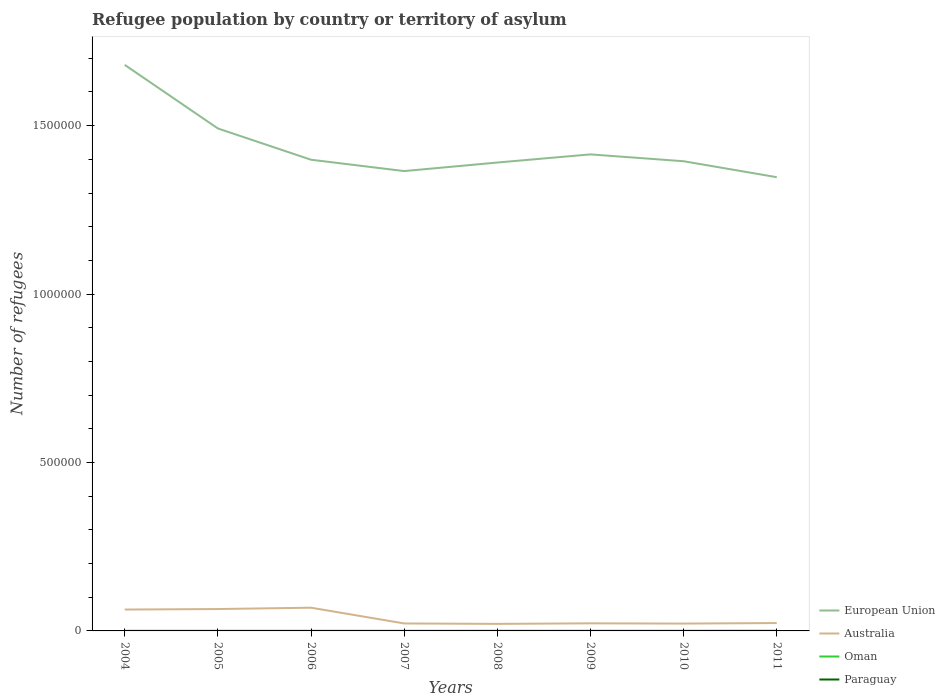How many different coloured lines are there?
Your answer should be very brief. 4. Does the line corresponding to Australia intersect with the line corresponding to Oman?
Provide a succinct answer. No. Is the number of lines equal to the number of legend labels?
Keep it short and to the point. Yes. In which year was the number of refugees in Paraguay maximum?
Provide a succinct answer. 2004. What is the total number of refugees in Australia in the graph?
Provide a succinct answer. -1629. What is the difference between the highest and the second highest number of refugees in Oman?
Offer a very short reply. 76. Is the number of refugees in Paraguay strictly greater than the number of refugees in Australia over the years?
Give a very brief answer. Yes. How many lines are there?
Your answer should be compact. 4. Are the values on the major ticks of Y-axis written in scientific E-notation?
Offer a terse response. No. Does the graph contain grids?
Provide a short and direct response. No. How many legend labels are there?
Provide a short and direct response. 4. What is the title of the graph?
Your response must be concise. Refugee population by country or territory of asylum. Does "Kiribati" appear as one of the legend labels in the graph?
Your answer should be compact. No. What is the label or title of the Y-axis?
Give a very brief answer. Number of refugees. What is the Number of refugees of European Union in 2004?
Provide a succinct answer. 1.68e+06. What is the Number of refugees in Australia in 2004?
Give a very brief answer. 6.35e+04. What is the Number of refugees in European Union in 2005?
Provide a short and direct response. 1.49e+06. What is the Number of refugees of Australia in 2005?
Your response must be concise. 6.50e+04. What is the Number of refugees in European Union in 2006?
Make the answer very short. 1.40e+06. What is the Number of refugees in Australia in 2006?
Make the answer very short. 6.89e+04. What is the Number of refugees in European Union in 2007?
Your answer should be compact. 1.37e+06. What is the Number of refugees of Australia in 2007?
Ensure brevity in your answer.  2.22e+04. What is the Number of refugees of European Union in 2008?
Offer a terse response. 1.39e+06. What is the Number of refugees of Australia in 2008?
Give a very brief answer. 2.09e+04. What is the Number of refugees in Oman in 2008?
Offer a terse response. 7. What is the Number of refugees of Paraguay in 2008?
Give a very brief answer. 75. What is the Number of refugees in European Union in 2009?
Offer a very short reply. 1.41e+06. What is the Number of refugees of Australia in 2009?
Your response must be concise. 2.25e+04. What is the Number of refugees of Paraguay in 2009?
Your response must be concise. 89. What is the Number of refugees in European Union in 2010?
Provide a succinct answer. 1.39e+06. What is the Number of refugees in Australia in 2010?
Keep it short and to the point. 2.18e+04. What is the Number of refugees in Oman in 2010?
Your answer should be very brief. 78. What is the Number of refugees of Paraguay in 2010?
Provide a succinct answer. 107. What is the Number of refugees in European Union in 2011?
Your answer should be very brief. 1.35e+06. What is the Number of refugees in Australia in 2011?
Make the answer very short. 2.34e+04. What is the Number of refugees of Oman in 2011?
Ensure brevity in your answer.  83. What is the Number of refugees in Paraguay in 2011?
Keep it short and to the point. 124. Across all years, what is the maximum Number of refugees in European Union?
Keep it short and to the point. 1.68e+06. Across all years, what is the maximum Number of refugees in Australia?
Offer a very short reply. 6.89e+04. Across all years, what is the maximum Number of refugees in Paraguay?
Ensure brevity in your answer.  124. Across all years, what is the minimum Number of refugees in European Union?
Your answer should be compact. 1.35e+06. Across all years, what is the minimum Number of refugees of Australia?
Keep it short and to the point. 2.09e+04. What is the total Number of refugees in European Union in the graph?
Offer a terse response. 1.15e+07. What is the total Number of refugees in Australia in the graph?
Give a very brief answer. 3.08e+05. What is the total Number of refugees of Oman in the graph?
Ensure brevity in your answer.  222. What is the total Number of refugees in Paraguay in the graph?
Provide a succinct answer. 607. What is the difference between the Number of refugees of European Union in 2004 and that in 2005?
Offer a terse response. 1.89e+05. What is the difference between the Number of refugees in Australia in 2004 and that in 2005?
Your answer should be compact. -1488. What is the difference between the Number of refugees in Oman in 2004 and that in 2005?
Provide a short and direct response. 0. What is the difference between the Number of refugees in European Union in 2004 and that in 2006?
Offer a very short reply. 2.82e+05. What is the difference between the Number of refugees in Australia in 2004 and that in 2006?
Your answer should be compact. -5472. What is the difference between the Number of refugees in Paraguay in 2004 and that in 2006?
Your answer should be very brief. -18. What is the difference between the Number of refugees in European Union in 2004 and that in 2007?
Give a very brief answer. 3.15e+05. What is the difference between the Number of refugees in Australia in 2004 and that in 2007?
Your response must be concise. 4.13e+04. What is the difference between the Number of refugees of Oman in 2004 and that in 2007?
Provide a succinct answer. 0. What is the difference between the Number of refugees of European Union in 2004 and that in 2008?
Your response must be concise. 2.90e+05. What is the difference between the Number of refugees in Australia in 2004 and that in 2008?
Make the answer very short. 4.26e+04. What is the difference between the Number of refugees in Oman in 2004 and that in 2008?
Your response must be concise. 0. What is the difference between the Number of refugees of Paraguay in 2004 and that in 2008?
Your answer should be compact. -34. What is the difference between the Number of refugees of European Union in 2004 and that in 2009?
Provide a short and direct response. 2.66e+05. What is the difference between the Number of refugees of Australia in 2004 and that in 2009?
Your answer should be very brief. 4.09e+04. What is the difference between the Number of refugees in Oman in 2004 and that in 2009?
Provide a succinct answer. -19. What is the difference between the Number of refugees in Paraguay in 2004 and that in 2009?
Your response must be concise. -48. What is the difference between the Number of refugees in European Union in 2004 and that in 2010?
Offer a very short reply. 2.86e+05. What is the difference between the Number of refugees in Australia in 2004 and that in 2010?
Offer a very short reply. 4.17e+04. What is the difference between the Number of refugees of Oman in 2004 and that in 2010?
Provide a succinct answer. -71. What is the difference between the Number of refugees of Paraguay in 2004 and that in 2010?
Give a very brief answer. -66. What is the difference between the Number of refugees in European Union in 2004 and that in 2011?
Provide a short and direct response. 3.33e+05. What is the difference between the Number of refugees in Australia in 2004 and that in 2011?
Offer a terse response. 4.00e+04. What is the difference between the Number of refugees of Oman in 2004 and that in 2011?
Offer a terse response. -76. What is the difference between the Number of refugees in Paraguay in 2004 and that in 2011?
Your answer should be compact. -83. What is the difference between the Number of refugees in European Union in 2005 and that in 2006?
Offer a terse response. 9.28e+04. What is the difference between the Number of refugees of Australia in 2005 and that in 2006?
Your response must be concise. -3984. What is the difference between the Number of refugees in European Union in 2005 and that in 2007?
Your answer should be very brief. 1.27e+05. What is the difference between the Number of refugees of Australia in 2005 and that in 2007?
Ensure brevity in your answer.  4.28e+04. What is the difference between the Number of refugees in Oman in 2005 and that in 2007?
Ensure brevity in your answer.  0. What is the difference between the Number of refugees of European Union in 2005 and that in 2008?
Offer a very short reply. 1.01e+05. What is the difference between the Number of refugees of Australia in 2005 and that in 2008?
Ensure brevity in your answer.  4.40e+04. What is the difference between the Number of refugees in Oman in 2005 and that in 2008?
Keep it short and to the point. 0. What is the difference between the Number of refugees of Paraguay in 2005 and that in 2008?
Your answer should be compact. -25. What is the difference between the Number of refugees in European Union in 2005 and that in 2009?
Offer a terse response. 7.70e+04. What is the difference between the Number of refugees of Australia in 2005 and that in 2009?
Offer a very short reply. 4.24e+04. What is the difference between the Number of refugees of Oman in 2005 and that in 2009?
Your answer should be compact. -19. What is the difference between the Number of refugees of Paraguay in 2005 and that in 2009?
Offer a very short reply. -39. What is the difference between the Number of refugees in European Union in 2005 and that in 2010?
Your answer should be compact. 9.73e+04. What is the difference between the Number of refugees in Australia in 2005 and that in 2010?
Your answer should be compact. 4.32e+04. What is the difference between the Number of refugees in Oman in 2005 and that in 2010?
Your response must be concise. -71. What is the difference between the Number of refugees in Paraguay in 2005 and that in 2010?
Give a very brief answer. -57. What is the difference between the Number of refugees in European Union in 2005 and that in 2011?
Your response must be concise. 1.45e+05. What is the difference between the Number of refugees in Australia in 2005 and that in 2011?
Give a very brief answer. 4.15e+04. What is the difference between the Number of refugees in Oman in 2005 and that in 2011?
Keep it short and to the point. -76. What is the difference between the Number of refugees of Paraguay in 2005 and that in 2011?
Your answer should be very brief. -74. What is the difference between the Number of refugees of European Union in 2006 and that in 2007?
Give a very brief answer. 3.37e+04. What is the difference between the Number of refugees of Australia in 2006 and that in 2007?
Give a very brief answer. 4.68e+04. What is the difference between the Number of refugees of Paraguay in 2006 and that in 2007?
Ensure brevity in your answer.  -3. What is the difference between the Number of refugees of European Union in 2006 and that in 2008?
Your answer should be very brief. 8328. What is the difference between the Number of refugees in Australia in 2006 and that in 2008?
Ensure brevity in your answer.  4.80e+04. What is the difference between the Number of refugees of Oman in 2006 and that in 2008?
Provide a short and direct response. 0. What is the difference between the Number of refugees of Paraguay in 2006 and that in 2008?
Offer a very short reply. -16. What is the difference between the Number of refugees of European Union in 2006 and that in 2009?
Your answer should be compact. -1.59e+04. What is the difference between the Number of refugees in Australia in 2006 and that in 2009?
Give a very brief answer. 4.64e+04. What is the difference between the Number of refugees in European Union in 2006 and that in 2010?
Ensure brevity in your answer.  4486. What is the difference between the Number of refugees of Australia in 2006 and that in 2010?
Your response must be concise. 4.71e+04. What is the difference between the Number of refugees of Oman in 2006 and that in 2010?
Provide a short and direct response. -71. What is the difference between the Number of refugees in Paraguay in 2006 and that in 2010?
Provide a succinct answer. -48. What is the difference between the Number of refugees of European Union in 2006 and that in 2011?
Provide a succinct answer. 5.18e+04. What is the difference between the Number of refugees of Australia in 2006 and that in 2011?
Offer a terse response. 4.55e+04. What is the difference between the Number of refugees in Oman in 2006 and that in 2011?
Offer a very short reply. -76. What is the difference between the Number of refugees of Paraguay in 2006 and that in 2011?
Offer a very short reply. -65. What is the difference between the Number of refugees of European Union in 2007 and that in 2008?
Ensure brevity in your answer.  -2.54e+04. What is the difference between the Number of refugees of Australia in 2007 and that in 2008?
Provide a succinct answer. 1245. What is the difference between the Number of refugees of European Union in 2007 and that in 2009?
Provide a succinct answer. -4.96e+04. What is the difference between the Number of refugees in Australia in 2007 and that in 2009?
Make the answer very short. -384. What is the difference between the Number of refugees in European Union in 2007 and that in 2010?
Your response must be concise. -2.92e+04. What is the difference between the Number of refugees in Australia in 2007 and that in 2010?
Ensure brevity in your answer.  359. What is the difference between the Number of refugees of Oman in 2007 and that in 2010?
Your answer should be compact. -71. What is the difference between the Number of refugees of Paraguay in 2007 and that in 2010?
Make the answer very short. -45. What is the difference between the Number of refugees in European Union in 2007 and that in 2011?
Give a very brief answer. 1.81e+04. What is the difference between the Number of refugees in Australia in 2007 and that in 2011?
Your answer should be very brief. -1270. What is the difference between the Number of refugees of Oman in 2007 and that in 2011?
Provide a succinct answer. -76. What is the difference between the Number of refugees of Paraguay in 2007 and that in 2011?
Provide a short and direct response. -62. What is the difference between the Number of refugees of European Union in 2008 and that in 2009?
Offer a terse response. -2.42e+04. What is the difference between the Number of refugees in Australia in 2008 and that in 2009?
Ensure brevity in your answer.  -1629. What is the difference between the Number of refugees in Paraguay in 2008 and that in 2009?
Ensure brevity in your answer.  -14. What is the difference between the Number of refugees of European Union in 2008 and that in 2010?
Give a very brief answer. -3842. What is the difference between the Number of refugees in Australia in 2008 and that in 2010?
Your answer should be compact. -886. What is the difference between the Number of refugees of Oman in 2008 and that in 2010?
Provide a short and direct response. -71. What is the difference between the Number of refugees in Paraguay in 2008 and that in 2010?
Offer a terse response. -32. What is the difference between the Number of refugees in European Union in 2008 and that in 2011?
Provide a succinct answer. 4.35e+04. What is the difference between the Number of refugees of Australia in 2008 and that in 2011?
Make the answer very short. -2515. What is the difference between the Number of refugees in Oman in 2008 and that in 2011?
Provide a short and direct response. -76. What is the difference between the Number of refugees in Paraguay in 2008 and that in 2011?
Offer a terse response. -49. What is the difference between the Number of refugees of European Union in 2009 and that in 2010?
Your answer should be very brief. 2.04e+04. What is the difference between the Number of refugees in Australia in 2009 and that in 2010?
Ensure brevity in your answer.  743. What is the difference between the Number of refugees of Oman in 2009 and that in 2010?
Offer a very short reply. -52. What is the difference between the Number of refugees in Paraguay in 2009 and that in 2010?
Keep it short and to the point. -18. What is the difference between the Number of refugees of European Union in 2009 and that in 2011?
Offer a terse response. 6.77e+04. What is the difference between the Number of refugees in Australia in 2009 and that in 2011?
Ensure brevity in your answer.  -886. What is the difference between the Number of refugees of Oman in 2009 and that in 2011?
Keep it short and to the point. -57. What is the difference between the Number of refugees in Paraguay in 2009 and that in 2011?
Your answer should be very brief. -35. What is the difference between the Number of refugees in European Union in 2010 and that in 2011?
Your answer should be very brief. 4.73e+04. What is the difference between the Number of refugees of Australia in 2010 and that in 2011?
Make the answer very short. -1629. What is the difference between the Number of refugees of Oman in 2010 and that in 2011?
Provide a succinct answer. -5. What is the difference between the Number of refugees of European Union in 2004 and the Number of refugees of Australia in 2005?
Keep it short and to the point. 1.62e+06. What is the difference between the Number of refugees in European Union in 2004 and the Number of refugees in Oman in 2005?
Offer a very short reply. 1.68e+06. What is the difference between the Number of refugees of European Union in 2004 and the Number of refugees of Paraguay in 2005?
Ensure brevity in your answer.  1.68e+06. What is the difference between the Number of refugees of Australia in 2004 and the Number of refugees of Oman in 2005?
Provide a succinct answer. 6.35e+04. What is the difference between the Number of refugees of Australia in 2004 and the Number of refugees of Paraguay in 2005?
Your answer should be very brief. 6.34e+04. What is the difference between the Number of refugees of Oman in 2004 and the Number of refugees of Paraguay in 2005?
Ensure brevity in your answer.  -43. What is the difference between the Number of refugees in European Union in 2004 and the Number of refugees in Australia in 2006?
Keep it short and to the point. 1.61e+06. What is the difference between the Number of refugees in European Union in 2004 and the Number of refugees in Oman in 2006?
Make the answer very short. 1.68e+06. What is the difference between the Number of refugees of European Union in 2004 and the Number of refugees of Paraguay in 2006?
Make the answer very short. 1.68e+06. What is the difference between the Number of refugees in Australia in 2004 and the Number of refugees in Oman in 2006?
Provide a succinct answer. 6.35e+04. What is the difference between the Number of refugees of Australia in 2004 and the Number of refugees of Paraguay in 2006?
Provide a succinct answer. 6.34e+04. What is the difference between the Number of refugees in Oman in 2004 and the Number of refugees in Paraguay in 2006?
Offer a very short reply. -52. What is the difference between the Number of refugees of European Union in 2004 and the Number of refugees of Australia in 2007?
Your answer should be very brief. 1.66e+06. What is the difference between the Number of refugees in European Union in 2004 and the Number of refugees in Oman in 2007?
Your response must be concise. 1.68e+06. What is the difference between the Number of refugees of European Union in 2004 and the Number of refugees of Paraguay in 2007?
Offer a very short reply. 1.68e+06. What is the difference between the Number of refugees in Australia in 2004 and the Number of refugees in Oman in 2007?
Give a very brief answer. 6.35e+04. What is the difference between the Number of refugees in Australia in 2004 and the Number of refugees in Paraguay in 2007?
Provide a short and direct response. 6.34e+04. What is the difference between the Number of refugees of Oman in 2004 and the Number of refugees of Paraguay in 2007?
Offer a terse response. -55. What is the difference between the Number of refugees of European Union in 2004 and the Number of refugees of Australia in 2008?
Ensure brevity in your answer.  1.66e+06. What is the difference between the Number of refugees in European Union in 2004 and the Number of refugees in Oman in 2008?
Provide a succinct answer. 1.68e+06. What is the difference between the Number of refugees in European Union in 2004 and the Number of refugees in Paraguay in 2008?
Offer a very short reply. 1.68e+06. What is the difference between the Number of refugees of Australia in 2004 and the Number of refugees of Oman in 2008?
Make the answer very short. 6.35e+04. What is the difference between the Number of refugees of Australia in 2004 and the Number of refugees of Paraguay in 2008?
Your answer should be very brief. 6.34e+04. What is the difference between the Number of refugees in Oman in 2004 and the Number of refugees in Paraguay in 2008?
Offer a terse response. -68. What is the difference between the Number of refugees of European Union in 2004 and the Number of refugees of Australia in 2009?
Your answer should be very brief. 1.66e+06. What is the difference between the Number of refugees of European Union in 2004 and the Number of refugees of Oman in 2009?
Give a very brief answer. 1.68e+06. What is the difference between the Number of refugees in European Union in 2004 and the Number of refugees in Paraguay in 2009?
Offer a terse response. 1.68e+06. What is the difference between the Number of refugees of Australia in 2004 and the Number of refugees of Oman in 2009?
Make the answer very short. 6.34e+04. What is the difference between the Number of refugees of Australia in 2004 and the Number of refugees of Paraguay in 2009?
Your answer should be compact. 6.34e+04. What is the difference between the Number of refugees in Oman in 2004 and the Number of refugees in Paraguay in 2009?
Ensure brevity in your answer.  -82. What is the difference between the Number of refugees of European Union in 2004 and the Number of refugees of Australia in 2010?
Your answer should be very brief. 1.66e+06. What is the difference between the Number of refugees in European Union in 2004 and the Number of refugees in Oman in 2010?
Your response must be concise. 1.68e+06. What is the difference between the Number of refugees in European Union in 2004 and the Number of refugees in Paraguay in 2010?
Offer a terse response. 1.68e+06. What is the difference between the Number of refugees in Australia in 2004 and the Number of refugees in Oman in 2010?
Your answer should be compact. 6.34e+04. What is the difference between the Number of refugees in Australia in 2004 and the Number of refugees in Paraguay in 2010?
Give a very brief answer. 6.34e+04. What is the difference between the Number of refugees in Oman in 2004 and the Number of refugees in Paraguay in 2010?
Make the answer very short. -100. What is the difference between the Number of refugees of European Union in 2004 and the Number of refugees of Australia in 2011?
Ensure brevity in your answer.  1.66e+06. What is the difference between the Number of refugees of European Union in 2004 and the Number of refugees of Oman in 2011?
Your answer should be very brief. 1.68e+06. What is the difference between the Number of refugees in European Union in 2004 and the Number of refugees in Paraguay in 2011?
Provide a succinct answer. 1.68e+06. What is the difference between the Number of refugees in Australia in 2004 and the Number of refugees in Oman in 2011?
Provide a short and direct response. 6.34e+04. What is the difference between the Number of refugees of Australia in 2004 and the Number of refugees of Paraguay in 2011?
Keep it short and to the point. 6.34e+04. What is the difference between the Number of refugees in Oman in 2004 and the Number of refugees in Paraguay in 2011?
Ensure brevity in your answer.  -117. What is the difference between the Number of refugees in European Union in 2005 and the Number of refugees in Australia in 2006?
Give a very brief answer. 1.42e+06. What is the difference between the Number of refugees of European Union in 2005 and the Number of refugees of Oman in 2006?
Provide a succinct answer. 1.49e+06. What is the difference between the Number of refugees of European Union in 2005 and the Number of refugees of Paraguay in 2006?
Keep it short and to the point. 1.49e+06. What is the difference between the Number of refugees of Australia in 2005 and the Number of refugees of Oman in 2006?
Offer a very short reply. 6.50e+04. What is the difference between the Number of refugees in Australia in 2005 and the Number of refugees in Paraguay in 2006?
Your response must be concise. 6.49e+04. What is the difference between the Number of refugees in Oman in 2005 and the Number of refugees in Paraguay in 2006?
Your answer should be very brief. -52. What is the difference between the Number of refugees of European Union in 2005 and the Number of refugees of Australia in 2007?
Offer a very short reply. 1.47e+06. What is the difference between the Number of refugees in European Union in 2005 and the Number of refugees in Oman in 2007?
Offer a very short reply. 1.49e+06. What is the difference between the Number of refugees of European Union in 2005 and the Number of refugees of Paraguay in 2007?
Provide a succinct answer. 1.49e+06. What is the difference between the Number of refugees of Australia in 2005 and the Number of refugees of Oman in 2007?
Give a very brief answer. 6.50e+04. What is the difference between the Number of refugees of Australia in 2005 and the Number of refugees of Paraguay in 2007?
Ensure brevity in your answer.  6.49e+04. What is the difference between the Number of refugees of Oman in 2005 and the Number of refugees of Paraguay in 2007?
Offer a terse response. -55. What is the difference between the Number of refugees in European Union in 2005 and the Number of refugees in Australia in 2008?
Your response must be concise. 1.47e+06. What is the difference between the Number of refugees of European Union in 2005 and the Number of refugees of Oman in 2008?
Your answer should be compact. 1.49e+06. What is the difference between the Number of refugees in European Union in 2005 and the Number of refugees in Paraguay in 2008?
Your answer should be very brief. 1.49e+06. What is the difference between the Number of refugees of Australia in 2005 and the Number of refugees of Oman in 2008?
Keep it short and to the point. 6.50e+04. What is the difference between the Number of refugees of Australia in 2005 and the Number of refugees of Paraguay in 2008?
Ensure brevity in your answer.  6.49e+04. What is the difference between the Number of refugees in Oman in 2005 and the Number of refugees in Paraguay in 2008?
Make the answer very short. -68. What is the difference between the Number of refugees in European Union in 2005 and the Number of refugees in Australia in 2009?
Your answer should be very brief. 1.47e+06. What is the difference between the Number of refugees in European Union in 2005 and the Number of refugees in Oman in 2009?
Make the answer very short. 1.49e+06. What is the difference between the Number of refugees of European Union in 2005 and the Number of refugees of Paraguay in 2009?
Offer a terse response. 1.49e+06. What is the difference between the Number of refugees of Australia in 2005 and the Number of refugees of Oman in 2009?
Provide a short and direct response. 6.49e+04. What is the difference between the Number of refugees of Australia in 2005 and the Number of refugees of Paraguay in 2009?
Ensure brevity in your answer.  6.49e+04. What is the difference between the Number of refugees of Oman in 2005 and the Number of refugees of Paraguay in 2009?
Your answer should be compact. -82. What is the difference between the Number of refugees of European Union in 2005 and the Number of refugees of Australia in 2010?
Keep it short and to the point. 1.47e+06. What is the difference between the Number of refugees in European Union in 2005 and the Number of refugees in Oman in 2010?
Offer a terse response. 1.49e+06. What is the difference between the Number of refugees of European Union in 2005 and the Number of refugees of Paraguay in 2010?
Your answer should be compact. 1.49e+06. What is the difference between the Number of refugees in Australia in 2005 and the Number of refugees in Oman in 2010?
Your answer should be compact. 6.49e+04. What is the difference between the Number of refugees in Australia in 2005 and the Number of refugees in Paraguay in 2010?
Your answer should be very brief. 6.49e+04. What is the difference between the Number of refugees in Oman in 2005 and the Number of refugees in Paraguay in 2010?
Offer a terse response. -100. What is the difference between the Number of refugees in European Union in 2005 and the Number of refugees in Australia in 2011?
Keep it short and to the point. 1.47e+06. What is the difference between the Number of refugees of European Union in 2005 and the Number of refugees of Oman in 2011?
Your answer should be compact. 1.49e+06. What is the difference between the Number of refugees of European Union in 2005 and the Number of refugees of Paraguay in 2011?
Provide a succinct answer. 1.49e+06. What is the difference between the Number of refugees in Australia in 2005 and the Number of refugees in Oman in 2011?
Offer a very short reply. 6.49e+04. What is the difference between the Number of refugees in Australia in 2005 and the Number of refugees in Paraguay in 2011?
Make the answer very short. 6.48e+04. What is the difference between the Number of refugees of Oman in 2005 and the Number of refugees of Paraguay in 2011?
Provide a short and direct response. -117. What is the difference between the Number of refugees of European Union in 2006 and the Number of refugees of Australia in 2007?
Offer a very short reply. 1.38e+06. What is the difference between the Number of refugees in European Union in 2006 and the Number of refugees in Oman in 2007?
Your answer should be compact. 1.40e+06. What is the difference between the Number of refugees in European Union in 2006 and the Number of refugees in Paraguay in 2007?
Your answer should be very brief. 1.40e+06. What is the difference between the Number of refugees in Australia in 2006 and the Number of refugees in Oman in 2007?
Ensure brevity in your answer.  6.89e+04. What is the difference between the Number of refugees in Australia in 2006 and the Number of refugees in Paraguay in 2007?
Offer a very short reply. 6.89e+04. What is the difference between the Number of refugees in Oman in 2006 and the Number of refugees in Paraguay in 2007?
Ensure brevity in your answer.  -55. What is the difference between the Number of refugees of European Union in 2006 and the Number of refugees of Australia in 2008?
Keep it short and to the point. 1.38e+06. What is the difference between the Number of refugees of European Union in 2006 and the Number of refugees of Oman in 2008?
Offer a terse response. 1.40e+06. What is the difference between the Number of refugees of European Union in 2006 and the Number of refugees of Paraguay in 2008?
Provide a short and direct response. 1.40e+06. What is the difference between the Number of refugees of Australia in 2006 and the Number of refugees of Oman in 2008?
Offer a terse response. 6.89e+04. What is the difference between the Number of refugees in Australia in 2006 and the Number of refugees in Paraguay in 2008?
Offer a terse response. 6.89e+04. What is the difference between the Number of refugees of Oman in 2006 and the Number of refugees of Paraguay in 2008?
Your answer should be compact. -68. What is the difference between the Number of refugees in European Union in 2006 and the Number of refugees in Australia in 2009?
Your answer should be compact. 1.38e+06. What is the difference between the Number of refugees in European Union in 2006 and the Number of refugees in Oman in 2009?
Make the answer very short. 1.40e+06. What is the difference between the Number of refugees in European Union in 2006 and the Number of refugees in Paraguay in 2009?
Offer a terse response. 1.40e+06. What is the difference between the Number of refugees of Australia in 2006 and the Number of refugees of Oman in 2009?
Provide a short and direct response. 6.89e+04. What is the difference between the Number of refugees of Australia in 2006 and the Number of refugees of Paraguay in 2009?
Your response must be concise. 6.89e+04. What is the difference between the Number of refugees of Oman in 2006 and the Number of refugees of Paraguay in 2009?
Give a very brief answer. -82. What is the difference between the Number of refugees in European Union in 2006 and the Number of refugees in Australia in 2010?
Your response must be concise. 1.38e+06. What is the difference between the Number of refugees in European Union in 2006 and the Number of refugees in Oman in 2010?
Your response must be concise. 1.40e+06. What is the difference between the Number of refugees in European Union in 2006 and the Number of refugees in Paraguay in 2010?
Your answer should be very brief. 1.40e+06. What is the difference between the Number of refugees of Australia in 2006 and the Number of refugees of Oman in 2010?
Give a very brief answer. 6.89e+04. What is the difference between the Number of refugees in Australia in 2006 and the Number of refugees in Paraguay in 2010?
Ensure brevity in your answer.  6.88e+04. What is the difference between the Number of refugees in Oman in 2006 and the Number of refugees in Paraguay in 2010?
Your response must be concise. -100. What is the difference between the Number of refugees in European Union in 2006 and the Number of refugees in Australia in 2011?
Offer a terse response. 1.38e+06. What is the difference between the Number of refugees of European Union in 2006 and the Number of refugees of Oman in 2011?
Provide a short and direct response. 1.40e+06. What is the difference between the Number of refugees of European Union in 2006 and the Number of refugees of Paraguay in 2011?
Offer a very short reply. 1.40e+06. What is the difference between the Number of refugees in Australia in 2006 and the Number of refugees in Oman in 2011?
Your answer should be very brief. 6.89e+04. What is the difference between the Number of refugees in Australia in 2006 and the Number of refugees in Paraguay in 2011?
Your answer should be very brief. 6.88e+04. What is the difference between the Number of refugees in Oman in 2006 and the Number of refugees in Paraguay in 2011?
Offer a terse response. -117. What is the difference between the Number of refugees of European Union in 2007 and the Number of refugees of Australia in 2008?
Make the answer very short. 1.34e+06. What is the difference between the Number of refugees of European Union in 2007 and the Number of refugees of Oman in 2008?
Keep it short and to the point. 1.37e+06. What is the difference between the Number of refugees in European Union in 2007 and the Number of refugees in Paraguay in 2008?
Keep it short and to the point. 1.37e+06. What is the difference between the Number of refugees of Australia in 2007 and the Number of refugees of Oman in 2008?
Your response must be concise. 2.22e+04. What is the difference between the Number of refugees of Australia in 2007 and the Number of refugees of Paraguay in 2008?
Give a very brief answer. 2.21e+04. What is the difference between the Number of refugees in Oman in 2007 and the Number of refugees in Paraguay in 2008?
Your answer should be compact. -68. What is the difference between the Number of refugees in European Union in 2007 and the Number of refugees in Australia in 2009?
Provide a succinct answer. 1.34e+06. What is the difference between the Number of refugees of European Union in 2007 and the Number of refugees of Oman in 2009?
Offer a terse response. 1.37e+06. What is the difference between the Number of refugees in European Union in 2007 and the Number of refugees in Paraguay in 2009?
Make the answer very short. 1.37e+06. What is the difference between the Number of refugees of Australia in 2007 and the Number of refugees of Oman in 2009?
Give a very brief answer. 2.21e+04. What is the difference between the Number of refugees of Australia in 2007 and the Number of refugees of Paraguay in 2009?
Your answer should be very brief. 2.21e+04. What is the difference between the Number of refugees of Oman in 2007 and the Number of refugees of Paraguay in 2009?
Offer a very short reply. -82. What is the difference between the Number of refugees of European Union in 2007 and the Number of refugees of Australia in 2010?
Your answer should be compact. 1.34e+06. What is the difference between the Number of refugees of European Union in 2007 and the Number of refugees of Oman in 2010?
Ensure brevity in your answer.  1.37e+06. What is the difference between the Number of refugees in European Union in 2007 and the Number of refugees in Paraguay in 2010?
Your response must be concise. 1.37e+06. What is the difference between the Number of refugees of Australia in 2007 and the Number of refugees of Oman in 2010?
Offer a terse response. 2.21e+04. What is the difference between the Number of refugees in Australia in 2007 and the Number of refugees in Paraguay in 2010?
Keep it short and to the point. 2.21e+04. What is the difference between the Number of refugees of Oman in 2007 and the Number of refugees of Paraguay in 2010?
Your answer should be compact. -100. What is the difference between the Number of refugees in European Union in 2007 and the Number of refugees in Australia in 2011?
Keep it short and to the point. 1.34e+06. What is the difference between the Number of refugees of European Union in 2007 and the Number of refugees of Oman in 2011?
Ensure brevity in your answer.  1.37e+06. What is the difference between the Number of refugees of European Union in 2007 and the Number of refugees of Paraguay in 2011?
Make the answer very short. 1.37e+06. What is the difference between the Number of refugees of Australia in 2007 and the Number of refugees of Oman in 2011?
Give a very brief answer. 2.21e+04. What is the difference between the Number of refugees in Australia in 2007 and the Number of refugees in Paraguay in 2011?
Offer a very short reply. 2.20e+04. What is the difference between the Number of refugees in Oman in 2007 and the Number of refugees in Paraguay in 2011?
Your response must be concise. -117. What is the difference between the Number of refugees in European Union in 2008 and the Number of refugees in Australia in 2009?
Your answer should be compact. 1.37e+06. What is the difference between the Number of refugees in European Union in 2008 and the Number of refugees in Oman in 2009?
Ensure brevity in your answer.  1.39e+06. What is the difference between the Number of refugees in European Union in 2008 and the Number of refugees in Paraguay in 2009?
Offer a terse response. 1.39e+06. What is the difference between the Number of refugees of Australia in 2008 and the Number of refugees of Oman in 2009?
Make the answer very short. 2.09e+04. What is the difference between the Number of refugees of Australia in 2008 and the Number of refugees of Paraguay in 2009?
Provide a short and direct response. 2.08e+04. What is the difference between the Number of refugees in Oman in 2008 and the Number of refugees in Paraguay in 2009?
Ensure brevity in your answer.  -82. What is the difference between the Number of refugees of European Union in 2008 and the Number of refugees of Australia in 2010?
Give a very brief answer. 1.37e+06. What is the difference between the Number of refugees of European Union in 2008 and the Number of refugees of Oman in 2010?
Your answer should be very brief. 1.39e+06. What is the difference between the Number of refugees of European Union in 2008 and the Number of refugees of Paraguay in 2010?
Offer a terse response. 1.39e+06. What is the difference between the Number of refugees of Australia in 2008 and the Number of refugees of Oman in 2010?
Provide a succinct answer. 2.08e+04. What is the difference between the Number of refugees in Australia in 2008 and the Number of refugees in Paraguay in 2010?
Offer a very short reply. 2.08e+04. What is the difference between the Number of refugees of Oman in 2008 and the Number of refugees of Paraguay in 2010?
Provide a short and direct response. -100. What is the difference between the Number of refugees of European Union in 2008 and the Number of refugees of Australia in 2011?
Offer a very short reply. 1.37e+06. What is the difference between the Number of refugees in European Union in 2008 and the Number of refugees in Oman in 2011?
Give a very brief answer. 1.39e+06. What is the difference between the Number of refugees of European Union in 2008 and the Number of refugees of Paraguay in 2011?
Your response must be concise. 1.39e+06. What is the difference between the Number of refugees in Australia in 2008 and the Number of refugees in Oman in 2011?
Offer a terse response. 2.08e+04. What is the difference between the Number of refugees of Australia in 2008 and the Number of refugees of Paraguay in 2011?
Provide a short and direct response. 2.08e+04. What is the difference between the Number of refugees of Oman in 2008 and the Number of refugees of Paraguay in 2011?
Your answer should be compact. -117. What is the difference between the Number of refugees of European Union in 2009 and the Number of refugees of Australia in 2010?
Provide a short and direct response. 1.39e+06. What is the difference between the Number of refugees of European Union in 2009 and the Number of refugees of Oman in 2010?
Provide a short and direct response. 1.41e+06. What is the difference between the Number of refugees of European Union in 2009 and the Number of refugees of Paraguay in 2010?
Your answer should be compact. 1.41e+06. What is the difference between the Number of refugees in Australia in 2009 and the Number of refugees in Oman in 2010?
Offer a very short reply. 2.25e+04. What is the difference between the Number of refugees of Australia in 2009 and the Number of refugees of Paraguay in 2010?
Keep it short and to the point. 2.24e+04. What is the difference between the Number of refugees in Oman in 2009 and the Number of refugees in Paraguay in 2010?
Ensure brevity in your answer.  -81. What is the difference between the Number of refugees of European Union in 2009 and the Number of refugees of Australia in 2011?
Offer a terse response. 1.39e+06. What is the difference between the Number of refugees of European Union in 2009 and the Number of refugees of Oman in 2011?
Offer a very short reply. 1.41e+06. What is the difference between the Number of refugees in European Union in 2009 and the Number of refugees in Paraguay in 2011?
Your answer should be very brief. 1.41e+06. What is the difference between the Number of refugees of Australia in 2009 and the Number of refugees of Oman in 2011?
Give a very brief answer. 2.25e+04. What is the difference between the Number of refugees in Australia in 2009 and the Number of refugees in Paraguay in 2011?
Offer a very short reply. 2.24e+04. What is the difference between the Number of refugees of Oman in 2009 and the Number of refugees of Paraguay in 2011?
Offer a terse response. -98. What is the difference between the Number of refugees of European Union in 2010 and the Number of refugees of Australia in 2011?
Keep it short and to the point. 1.37e+06. What is the difference between the Number of refugees of European Union in 2010 and the Number of refugees of Oman in 2011?
Keep it short and to the point. 1.39e+06. What is the difference between the Number of refugees of European Union in 2010 and the Number of refugees of Paraguay in 2011?
Make the answer very short. 1.39e+06. What is the difference between the Number of refugees in Australia in 2010 and the Number of refugees in Oman in 2011?
Provide a short and direct response. 2.17e+04. What is the difference between the Number of refugees of Australia in 2010 and the Number of refugees of Paraguay in 2011?
Your response must be concise. 2.17e+04. What is the difference between the Number of refugees of Oman in 2010 and the Number of refugees of Paraguay in 2011?
Keep it short and to the point. -46. What is the average Number of refugees in European Union per year?
Offer a terse response. 1.44e+06. What is the average Number of refugees of Australia per year?
Give a very brief answer. 3.85e+04. What is the average Number of refugees of Oman per year?
Your answer should be very brief. 27.75. What is the average Number of refugees in Paraguay per year?
Offer a very short reply. 75.88. In the year 2004, what is the difference between the Number of refugees of European Union and Number of refugees of Australia?
Provide a short and direct response. 1.62e+06. In the year 2004, what is the difference between the Number of refugees in European Union and Number of refugees in Oman?
Give a very brief answer. 1.68e+06. In the year 2004, what is the difference between the Number of refugees in European Union and Number of refugees in Paraguay?
Give a very brief answer. 1.68e+06. In the year 2004, what is the difference between the Number of refugees in Australia and Number of refugees in Oman?
Keep it short and to the point. 6.35e+04. In the year 2004, what is the difference between the Number of refugees in Australia and Number of refugees in Paraguay?
Ensure brevity in your answer.  6.34e+04. In the year 2004, what is the difference between the Number of refugees in Oman and Number of refugees in Paraguay?
Provide a succinct answer. -34. In the year 2005, what is the difference between the Number of refugees of European Union and Number of refugees of Australia?
Your answer should be compact. 1.43e+06. In the year 2005, what is the difference between the Number of refugees in European Union and Number of refugees in Oman?
Give a very brief answer. 1.49e+06. In the year 2005, what is the difference between the Number of refugees in European Union and Number of refugees in Paraguay?
Make the answer very short. 1.49e+06. In the year 2005, what is the difference between the Number of refugees in Australia and Number of refugees in Oman?
Your answer should be very brief. 6.50e+04. In the year 2005, what is the difference between the Number of refugees of Australia and Number of refugees of Paraguay?
Your response must be concise. 6.49e+04. In the year 2005, what is the difference between the Number of refugees in Oman and Number of refugees in Paraguay?
Your answer should be compact. -43. In the year 2006, what is the difference between the Number of refugees in European Union and Number of refugees in Australia?
Your answer should be very brief. 1.33e+06. In the year 2006, what is the difference between the Number of refugees in European Union and Number of refugees in Oman?
Provide a succinct answer. 1.40e+06. In the year 2006, what is the difference between the Number of refugees in European Union and Number of refugees in Paraguay?
Offer a terse response. 1.40e+06. In the year 2006, what is the difference between the Number of refugees of Australia and Number of refugees of Oman?
Give a very brief answer. 6.89e+04. In the year 2006, what is the difference between the Number of refugees in Australia and Number of refugees in Paraguay?
Keep it short and to the point. 6.89e+04. In the year 2006, what is the difference between the Number of refugees of Oman and Number of refugees of Paraguay?
Provide a short and direct response. -52. In the year 2007, what is the difference between the Number of refugees of European Union and Number of refugees of Australia?
Offer a terse response. 1.34e+06. In the year 2007, what is the difference between the Number of refugees in European Union and Number of refugees in Oman?
Ensure brevity in your answer.  1.37e+06. In the year 2007, what is the difference between the Number of refugees in European Union and Number of refugees in Paraguay?
Ensure brevity in your answer.  1.37e+06. In the year 2007, what is the difference between the Number of refugees in Australia and Number of refugees in Oman?
Offer a very short reply. 2.22e+04. In the year 2007, what is the difference between the Number of refugees in Australia and Number of refugees in Paraguay?
Give a very brief answer. 2.21e+04. In the year 2007, what is the difference between the Number of refugees of Oman and Number of refugees of Paraguay?
Offer a very short reply. -55. In the year 2008, what is the difference between the Number of refugees of European Union and Number of refugees of Australia?
Offer a terse response. 1.37e+06. In the year 2008, what is the difference between the Number of refugees of European Union and Number of refugees of Oman?
Keep it short and to the point. 1.39e+06. In the year 2008, what is the difference between the Number of refugees of European Union and Number of refugees of Paraguay?
Your response must be concise. 1.39e+06. In the year 2008, what is the difference between the Number of refugees in Australia and Number of refugees in Oman?
Provide a succinct answer. 2.09e+04. In the year 2008, what is the difference between the Number of refugees in Australia and Number of refugees in Paraguay?
Give a very brief answer. 2.08e+04. In the year 2008, what is the difference between the Number of refugees of Oman and Number of refugees of Paraguay?
Keep it short and to the point. -68. In the year 2009, what is the difference between the Number of refugees of European Union and Number of refugees of Australia?
Make the answer very short. 1.39e+06. In the year 2009, what is the difference between the Number of refugees of European Union and Number of refugees of Oman?
Ensure brevity in your answer.  1.41e+06. In the year 2009, what is the difference between the Number of refugees in European Union and Number of refugees in Paraguay?
Your response must be concise. 1.41e+06. In the year 2009, what is the difference between the Number of refugees in Australia and Number of refugees in Oman?
Offer a terse response. 2.25e+04. In the year 2009, what is the difference between the Number of refugees in Australia and Number of refugees in Paraguay?
Make the answer very short. 2.25e+04. In the year 2009, what is the difference between the Number of refugees in Oman and Number of refugees in Paraguay?
Offer a very short reply. -63. In the year 2010, what is the difference between the Number of refugees of European Union and Number of refugees of Australia?
Ensure brevity in your answer.  1.37e+06. In the year 2010, what is the difference between the Number of refugees of European Union and Number of refugees of Oman?
Your answer should be very brief. 1.39e+06. In the year 2010, what is the difference between the Number of refugees of European Union and Number of refugees of Paraguay?
Provide a short and direct response. 1.39e+06. In the year 2010, what is the difference between the Number of refugees of Australia and Number of refugees of Oman?
Ensure brevity in your answer.  2.17e+04. In the year 2010, what is the difference between the Number of refugees of Australia and Number of refugees of Paraguay?
Give a very brief answer. 2.17e+04. In the year 2011, what is the difference between the Number of refugees of European Union and Number of refugees of Australia?
Give a very brief answer. 1.32e+06. In the year 2011, what is the difference between the Number of refugees of European Union and Number of refugees of Oman?
Keep it short and to the point. 1.35e+06. In the year 2011, what is the difference between the Number of refugees of European Union and Number of refugees of Paraguay?
Offer a very short reply. 1.35e+06. In the year 2011, what is the difference between the Number of refugees of Australia and Number of refugees of Oman?
Your response must be concise. 2.34e+04. In the year 2011, what is the difference between the Number of refugees of Australia and Number of refugees of Paraguay?
Provide a succinct answer. 2.33e+04. In the year 2011, what is the difference between the Number of refugees of Oman and Number of refugees of Paraguay?
Your response must be concise. -41. What is the ratio of the Number of refugees of European Union in 2004 to that in 2005?
Your answer should be compact. 1.13. What is the ratio of the Number of refugees of Australia in 2004 to that in 2005?
Provide a succinct answer. 0.98. What is the ratio of the Number of refugees of Paraguay in 2004 to that in 2005?
Make the answer very short. 0.82. What is the ratio of the Number of refugees in European Union in 2004 to that in 2006?
Make the answer very short. 1.2. What is the ratio of the Number of refugees in Australia in 2004 to that in 2006?
Offer a terse response. 0.92. What is the ratio of the Number of refugees in Paraguay in 2004 to that in 2006?
Provide a succinct answer. 0.69. What is the ratio of the Number of refugees in European Union in 2004 to that in 2007?
Provide a short and direct response. 1.23. What is the ratio of the Number of refugees in Australia in 2004 to that in 2007?
Your response must be concise. 2.86. What is the ratio of the Number of refugees in Oman in 2004 to that in 2007?
Offer a very short reply. 1. What is the ratio of the Number of refugees of Paraguay in 2004 to that in 2007?
Provide a succinct answer. 0.66. What is the ratio of the Number of refugees in European Union in 2004 to that in 2008?
Give a very brief answer. 1.21. What is the ratio of the Number of refugees in Australia in 2004 to that in 2008?
Your answer should be compact. 3.03. What is the ratio of the Number of refugees in Paraguay in 2004 to that in 2008?
Offer a terse response. 0.55. What is the ratio of the Number of refugees in European Union in 2004 to that in 2009?
Make the answer very short. 1.19. What is the ratio of the Number of refugees in Australia in 2004 to that in 2009?
Ensure brevity in your answer.  2.82. What is the ratio of the Number of refugees in Oman in 2004 to that in 2009?
Offer a very short reply. 0.27. What is the ratio of the Number of refugees of Paraguay in 2004 to that in 2009?
Offer a very short reply. 0.46. What is the ratio of the Number of refugees of European Union in 2004 to that in 2010?
Provide a succinct answer. 1.21. What is the ratio of the Number of refugees of Australia in 2004 to that in 2010?
Keep it short and to the point. 2.91. What is the ratio of the Number of refugees in Oman in 2004 to that in 2010?
Offer a very short reply. 0.09. What is the ratio of the Number of refugees in Paraguay in 2004 to that in 2010?
Give a very brief answer. 0.38. What is the ratio of the Number of refugees in European Union in 2004 to that in 2011?
Provide a succinct answer. 1.25. What is the ratio of the Number of refugees in Australia in 2004 to that in 2011?
Give a very brief answer. 2.71. What is the ratio of the Number of refugees in Oman in 2004 to that in 2011?
Make the answer very short. 0.08. What is the ratio of the Number of refugees in Paraguay in 2004 to that in 2011?
Ensure brevity in your answer.  0.33. What is the ratio of the Number of refugees of European Union in 2005 to that in 2006?
Keep it short and to the point. 1.07. What is the ratio of the Number of refugees in Australia in 2005 to that in 2006?
Make the answer very short. 0.94. What is the ratio of the Number of refugees in Paraguay in 2005 to that in 2006?
Offer a very short reply. 0.85. What is the ratio of the Number of refugees in European Union in 2005 to that in 2007?
Your response must be concise. 1.09. What is the ratio of the Number of refugees of Australia in 2005 to that in 2007?
Offer a terse response. 2.93. What is the ratio of the Number of refugees of Oman in 2005 to that in 2007?
Offer a terse response. 1. What is the ratio of the Number of refugees in Paraguay in 2005 to that in 2007?
Give a very brief answer. 0.81. What is the ratio of the Number of refugees in European Union in 2005 to that in 2008?
Your response must be concise. 1.07. What is the ratio of the Number of refugees of Australia in 2005 to that in 2008?
Give a very brief answer. 3.11. What is the ratio of the Number of refugees in Oman in 2005 to that in 2008?
Offer a very short reply. 1. What is the ratio of the Number of refugees of European Union in 2005 to that in 2009?
Ensure brevity in your answer.  1.05. What is the ratio of the Number of refugees of Australia in 2005 to that in 2009?
Offer a terse response. 2.88. What is the ratio of the Number of refugees in Oman in 2005 to that in 2009?
Your answer should be compact. 0.27. What is the ratio of the Number of refugees of Paraguay in 2005 to that in 2009?
Provide a short and direct response. 0.56. What is the ratio of the Number of refugees in European Union in 2005 to that in 2010?
Ensure brevity in your answer.  1.07. What is the ratio of the Number of refugees in Australia in 2005 to that in 2010?
Make the answer very short. 2.98. What is the ratio of the Number of refugees in Oman in 2005 to that in 2010?
Provide a succinct answer. 0.09. What is the ratio of the Number of refugees in Paraguay in 2005 to that in 2010?
Your answer should be compact. 0.47. What is the ratio of the Number of refugees of European Union in 2005 to that in 2011?
Provide a short and direct response. 1.11. What is the ratio of the Number of refugees in Australia in 2005 to that in 2011?
Your answer should be compact. 2.77. What is the ratio of the Number of refugees of Oman in 2005 to that in 2011?
Provide a succinct answer. 0.08. What is the ratio of the Number of refugees in Paraguay in 2005 to that in 2011?
Your answer should be very brief. 0.4. What is the ratio of the Number of refugees of European Union in 2006 to that in 2007?
Offer a terse response. 1.02. What is the ratio of the Number of refugees of Australia in 2006 to that in 2007?
Ensure brevity in your answer.  3.11. What is the ratio of the Number of refugees of Oman in 2006 to that in 2007?
Make the answer very short. 1. What is the ratio of the Number of refugees of Paraguay in 2006 to that in 2007?
Your answer should be compact. 0.95. What is the ratio of the Number of refugees in Australia in 2006 to that in 2008?
Ensure brevity in your answer.  3.3. What is the ratio of the Number of refugees of Paraguay in 2006 to that in 2008?
Your answer should be compact. 0.79. What is the ratio of the Number of refugees of Australia in 2006 to that in 2009?
Offer a very short reply. 3.06. What is the ratio of the Number of refugees of Oman in 2006 to that in 2009?
Your answer should be very brief. 0.27. What is the ratio of the Number of refugees of Paraguay in 2006 to that in 2009?
Make the answer very short. 0.66. What is the ratio of the Number of refugees of Australia in 2006 to that in 2010?
Your response must be concise. 3.16. What is the ratio of the Number of refugees in Oman in 2006 to that in 2010?
Keep it short and to the point. 0.09. What is the ratio of the Number of refugees in Paraguay in 2006 to that in 2010?
Offer a very short reply. 0.55. What is the ratio of the Number of refugees of European Union in 2006 to that in 2011?
Offer a terse response. 1.04. What is the ratio of the Number of refugees in Australia in 2006 to that in 2011?
Keep it short and to the point. 2.94. What is the ratio of the Number of refugees of Oman in 2006 to that in 2011?
Provide a short and direct response. 0.08. What is the ratio of the Number of refugees in Paraguay in 2006 to that in 2011?
Give a very brief answer. 0.48. What is the ratio of the Number of refugees in European Union in 2007 to that in 2008?
Provide a succinct answer. 0.98. What is the ratio of the Number of refugees in Australia in 2007 to that in 2008?
Your response must be concise. 1.06. What is the ratio of the Number of refugees of Oman in 2007 to that in 2008?
Make the answer very short. 1. What is the ratio of the Number of refugees of Paraguay in 2007 to that in 2008?
Your response must be concise. 0.83. What is the ratio of the Number of refugees in European Union in 2007 to that in 2009?
Your answer should be compact. 0.96. What is the ratio of the Number of refugees in Oman in 2007 to that in 2009?
Provide a succinct answer. 0.27. What is the ratio of the Number of refugees in Paraguay in 2007 to that in 2009?
Your response must be concise. 0.7. What is the ratio of the Number of refugees of European Union in 2007 to that in 2010?
Your answer should be compact. 0.98. What is the ratio of the Number of refugees of Australia in 2007 to that in 2010?
Your answer should be very brief. 1.02. What is the ratio of the Number of refugees of Oman in 2007 to that in 2010?
Your answer should be very brief. 0.09. What is the ratio of the Number of refugees in Paraguay in 2007 to that in 2010?
Your answer should be very brief. 0.58. What is the ratio of the Number of refugees in European Union in 2007 to that in 2011?
Your answer should be very brief. 1.01. What is the ratio of the Number of refugees of Australia in 2007 to that in 2011?
Make the answer very short. 0.95. What is the ratio of the Number of refugees of Oman in 2007 to that in 2011?
Keep it short and to the point. 0.08. What is the ratio of the Number of refugees of Paraguay in 2007 to that in 2011?
Ensure brevity in your answer.  0.5. What is the ratio of the Number of refugees of European Union in 2008 to that in 2009?
Keep it short and to the point. 0.98. What is the ratio of the Number of refugees in Australia in 2008 to that in 2009?
Provide a short and direct response. 0.93. What is the ratio of the Number of refugees of Oman in 2008 to that in 2009?
Provide a succinct answer. 0.27. What is the ratio of the Number of refugees in Paraguay in 2008 to that in 2009?
Make the answer very short. 0.84. What is the ratio of the Number of refugees in Australia in 2008 to that in 2010?
Give a very brief answer. 0.96. What is the ratio of the Number of refugees of Oman in 2008 to that in 2010?
Your response must be concise. 0.09. What is the ratio of the Number of refugees of Paraguay in 2008 to that in 2010?
Your answer should be compact. 0.7. What is the ratio of the Number of refugees of European Union in 2008 to that in 2011?
Give a very brief answer. 1.03. What is the ratio of the Number of refugees of Australia in 2008 to that in 2011?
Provide a short and direct response. 0.89. What is the ratio of the Number of refugees in Oman in 2008 to that in 2011?
Provide a short and direct response. 0.08. What is the ratio of the Number of refugees of Paraguay in 2008 to that in 2011?
Keep it short and to the point. 0.6. What is the ratio of the Number of refugees of European Union in 2009 to that in 2010?
Provide a short and direct response. 1.01. What is the ratio of the Number of refugees of Australia in 2009 to that in 2010?
Ensure brevity in your answer.  1.03. What is the ratio of the Number of refugees of Paraguay in 2009 to that in 2010?
Your response must be concise. 0.83. What is the ratio of the Number of refugees of European Union in 2009 to that in 2011?
Offer a very short reply. 1.05. What is the ratio of the Number of refugees of Australia in 2009 to that in 2011?
Ensure brevity in your answer.  0.96. What is the ratio of the Number of refugees of Oman in 2009 to that in 2011?
Give a very brief answer. 0.31. What is the ratio of the Number of refugees of Paraguay in 2009 to that in 2011?
Offer a terse response. 0.72. What is the ratio of the Number of refugees of European Union in 2010 to that in 2011?
Provide a succinct answer. 1.04. What is the ratio of the Number of refugees in Australia in 2010 to that in 2011?
Offer a terse response. 0.93. What is the ratio of the Number of refugees of Oman in 2010 to that in 2011?
Give a very brief answer. 0.94. What is the ratio of the Number of refugees in Paraguay in 2010 to that in 2011?
Ensure brevity in your answer.  0.86. What is the difference between the highest and the second highest Number of refugees of European Union?
Give a very brief answer. 1.89e+05. What is the difference between the highest and the second highest Number of refugees of Australia?
Ensure brevity in your answer.  3984. What is the difference between the highest and the second highest Number of refugees of Oman?
Your answer should be compact. 5. What is the difference between the highest and the second highest Number of refugees in Paraguay?
Ensure brevity in your answer.  17. What is the difference between the highest and the lowest Number of refugees of European Union?
Your answer should be compact. 3.33e+05. What is the difference between the highest and the lowest Number of refugees of Australia?
Your answer should be compact. 4.80e+04. 